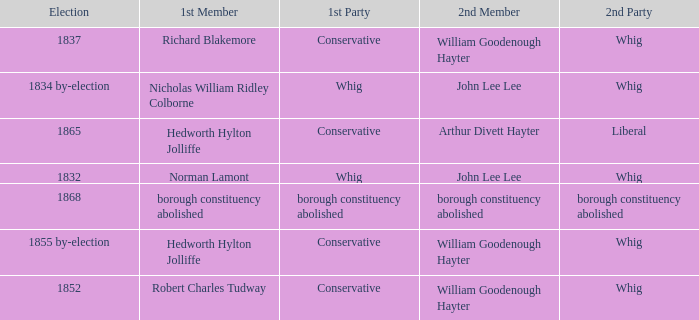Write the full table. {'header': ['Election', '1st Member', '1st Party', '2nd Member', '2nd Party'], 'rows': [['1837', 'Richard Blakemore', 'Conservative', 'William Goodenough Hayter', 'Whig'], ['1834 by-election', 'Nicholas William Ridley Colborne', 'Whig', 'John Lee Lee', 'Whig'], ['1865', 'Hedworth Hylton Jolliffe', 'Conservative', 'Arthur Divett Hayter', 'Liberal'], ['1832', 'Norman Lamont', 'Whig', 'John Lee Lee', 'Whig'], ['1868', 'borough constituency abolished', 'borough constituency abolished', 'borough constituency abolished', 'borough constituency abolished'], ['1855 by-election', 'Hedworth Hylton Jolliffe', 'Conservative', 'William Goodenough Hayter', 'Whig'], ['1852', 'Robert Charles Tudway', 'Conservative', 'William Goodenough Hayter', 'Whig']]} Who's the conservative 1st member of the election of 1852? Robert Charles Tudway. 